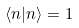<formula> <loc_0><loc_0><loc_500><loc_500>\langle n | n \rangle = 1</formula> 